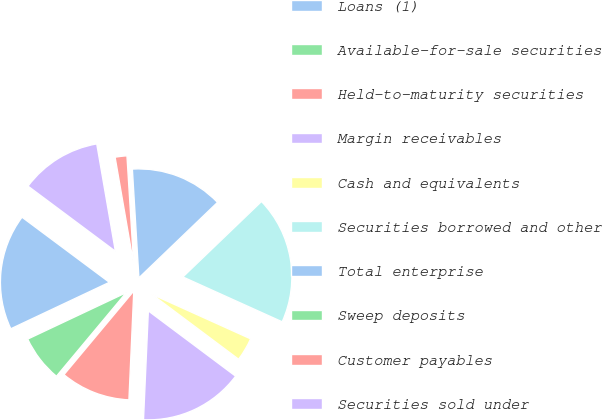Convert chart. <chart><loc_0><loc_0><loc_500><loc_500><pie_chart><fcel>Loans (1)<fcel>Available-for-sale securities<fcel>Held-to-maturity securities<fcel>Margin receivables<fcel>Cash and equivalents<fcel>Securities borrowed and other<fcel>Total enterprise<fcel>Sweep deposits<fcel>Customer payables<fcel>Securities sold under<nl><fcel>17.21%<fcel>6.92%<fcel>10.36%<fcel>15.49%<fcel>3.47%<fcel>18.93%<fcel>13.78%<fcel>0.03%<fcel>1.75%<fcel>12.07%<nl></chart> 